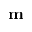<formula> <loc_0><loc_0><loc_500><loc_500>m</formula> 